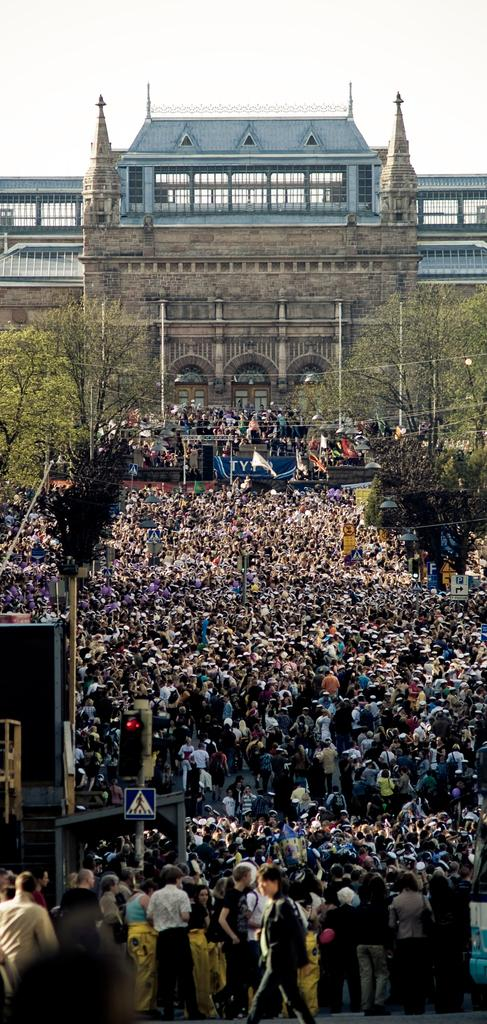What type of structure is visible in the image? There is a building in the image. Who or what else can be seen in the image? There is a crowd of people in the image. What type of vegetation is present on both sides of the image? There are trees on both sides of the image. What other objects can be seen in the image? There are poles in the image. What is the color of the sky in the image? The sky is white in color. What type of shoes are being selected by the people in the image? There is no mention of shoes or a selection process in the image; it features a building, a crowd of people, trees, poles, and a white sky. 